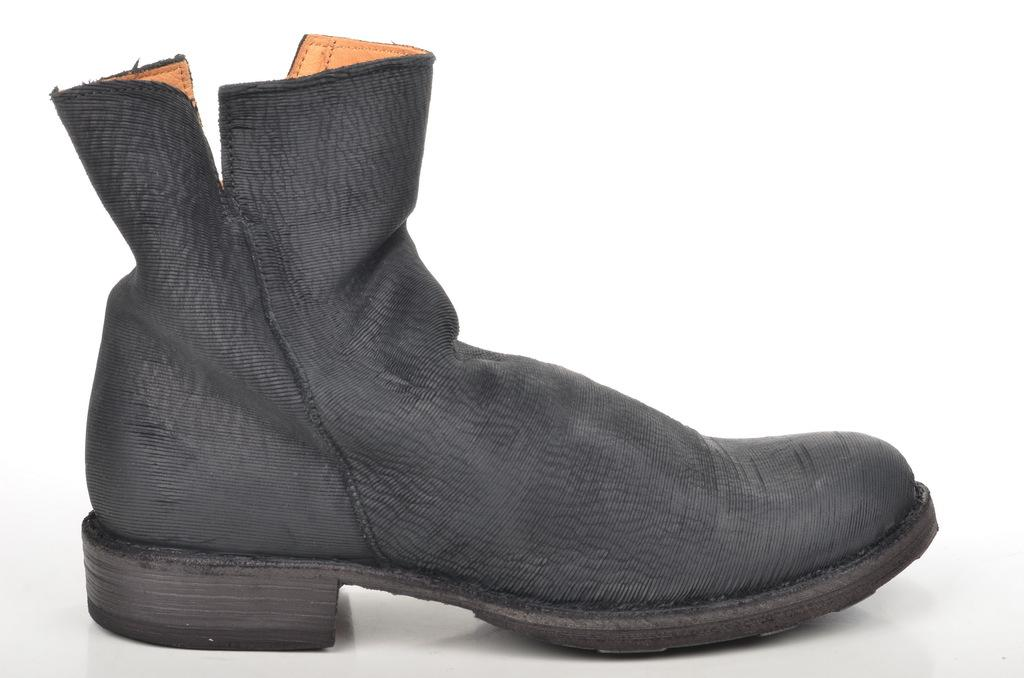What object is present in the image? There is a boot in the image. What color is the boot? The boot is black in color. What type of roof can be seen on the boot in the image? There is no roof present on the boot in the image, as it is a single object and not a structure. 